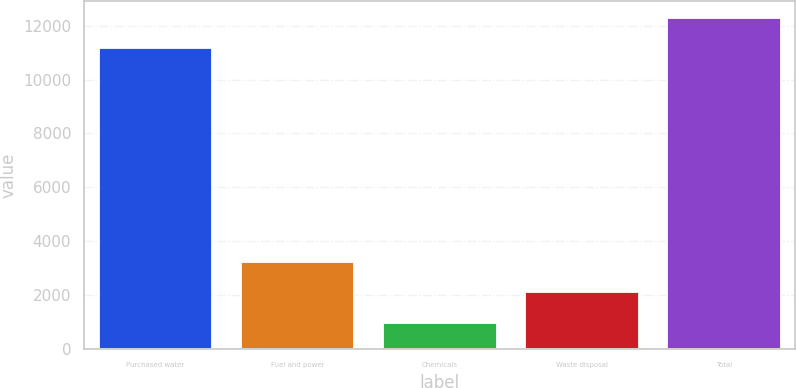Convert chart to OTSL. <chart><loc_0><loc_0><loc_500><loc_500><bar_chart><fcel>Purchased water<fcel>Fuel and power<fcel>Chemicals<fcel>Waste disposal<fcel>Total<nl><fcel>11165<fcel>3226.4<fcel>980<fcel>2103.2<fcel>12288.2<nl></chart> 